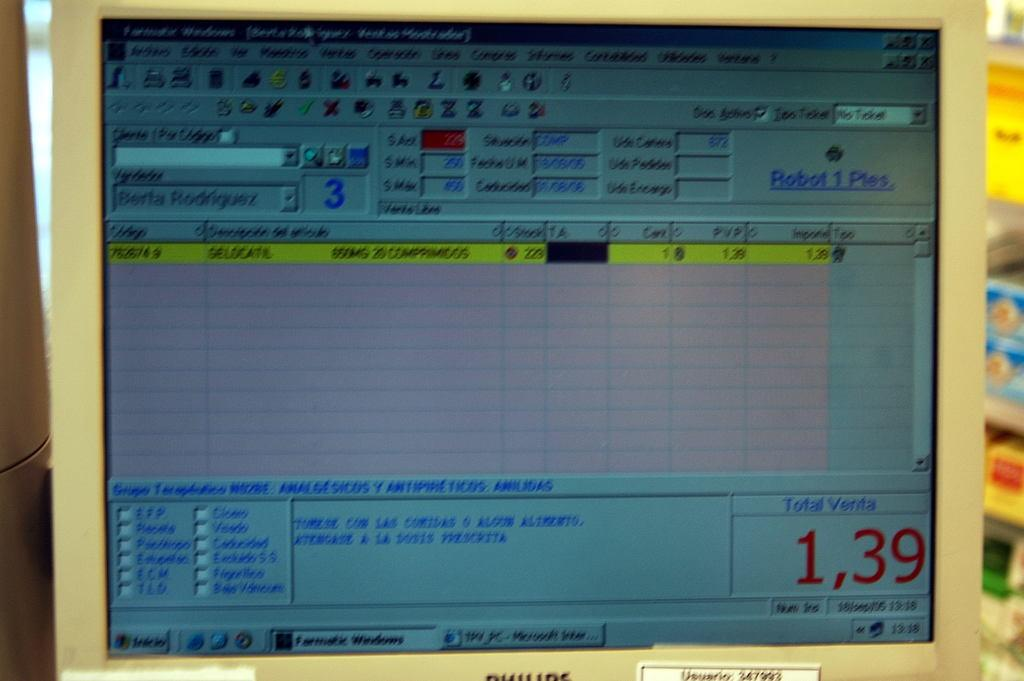What is displayed on the screen in the image? There is a screen with information in the image. Can you describe the condition of the right side of the image? The right side portion of the image is blurred. What type of fish can be seen swimming in the grass on the left side of the image? There is no fish or grass present in the image; it only features a screen with information and a blurred right side. 